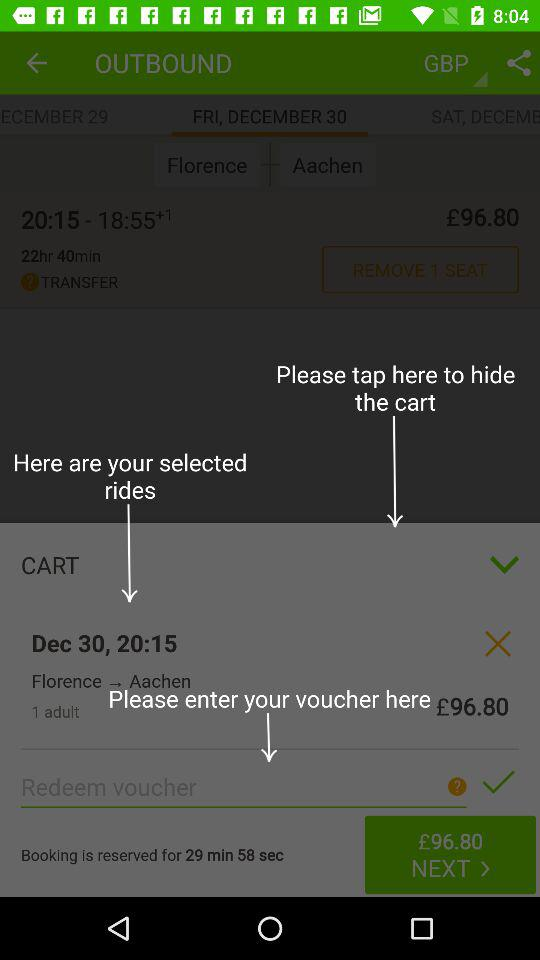What is the total number of adults? The total number of adults is 1. 